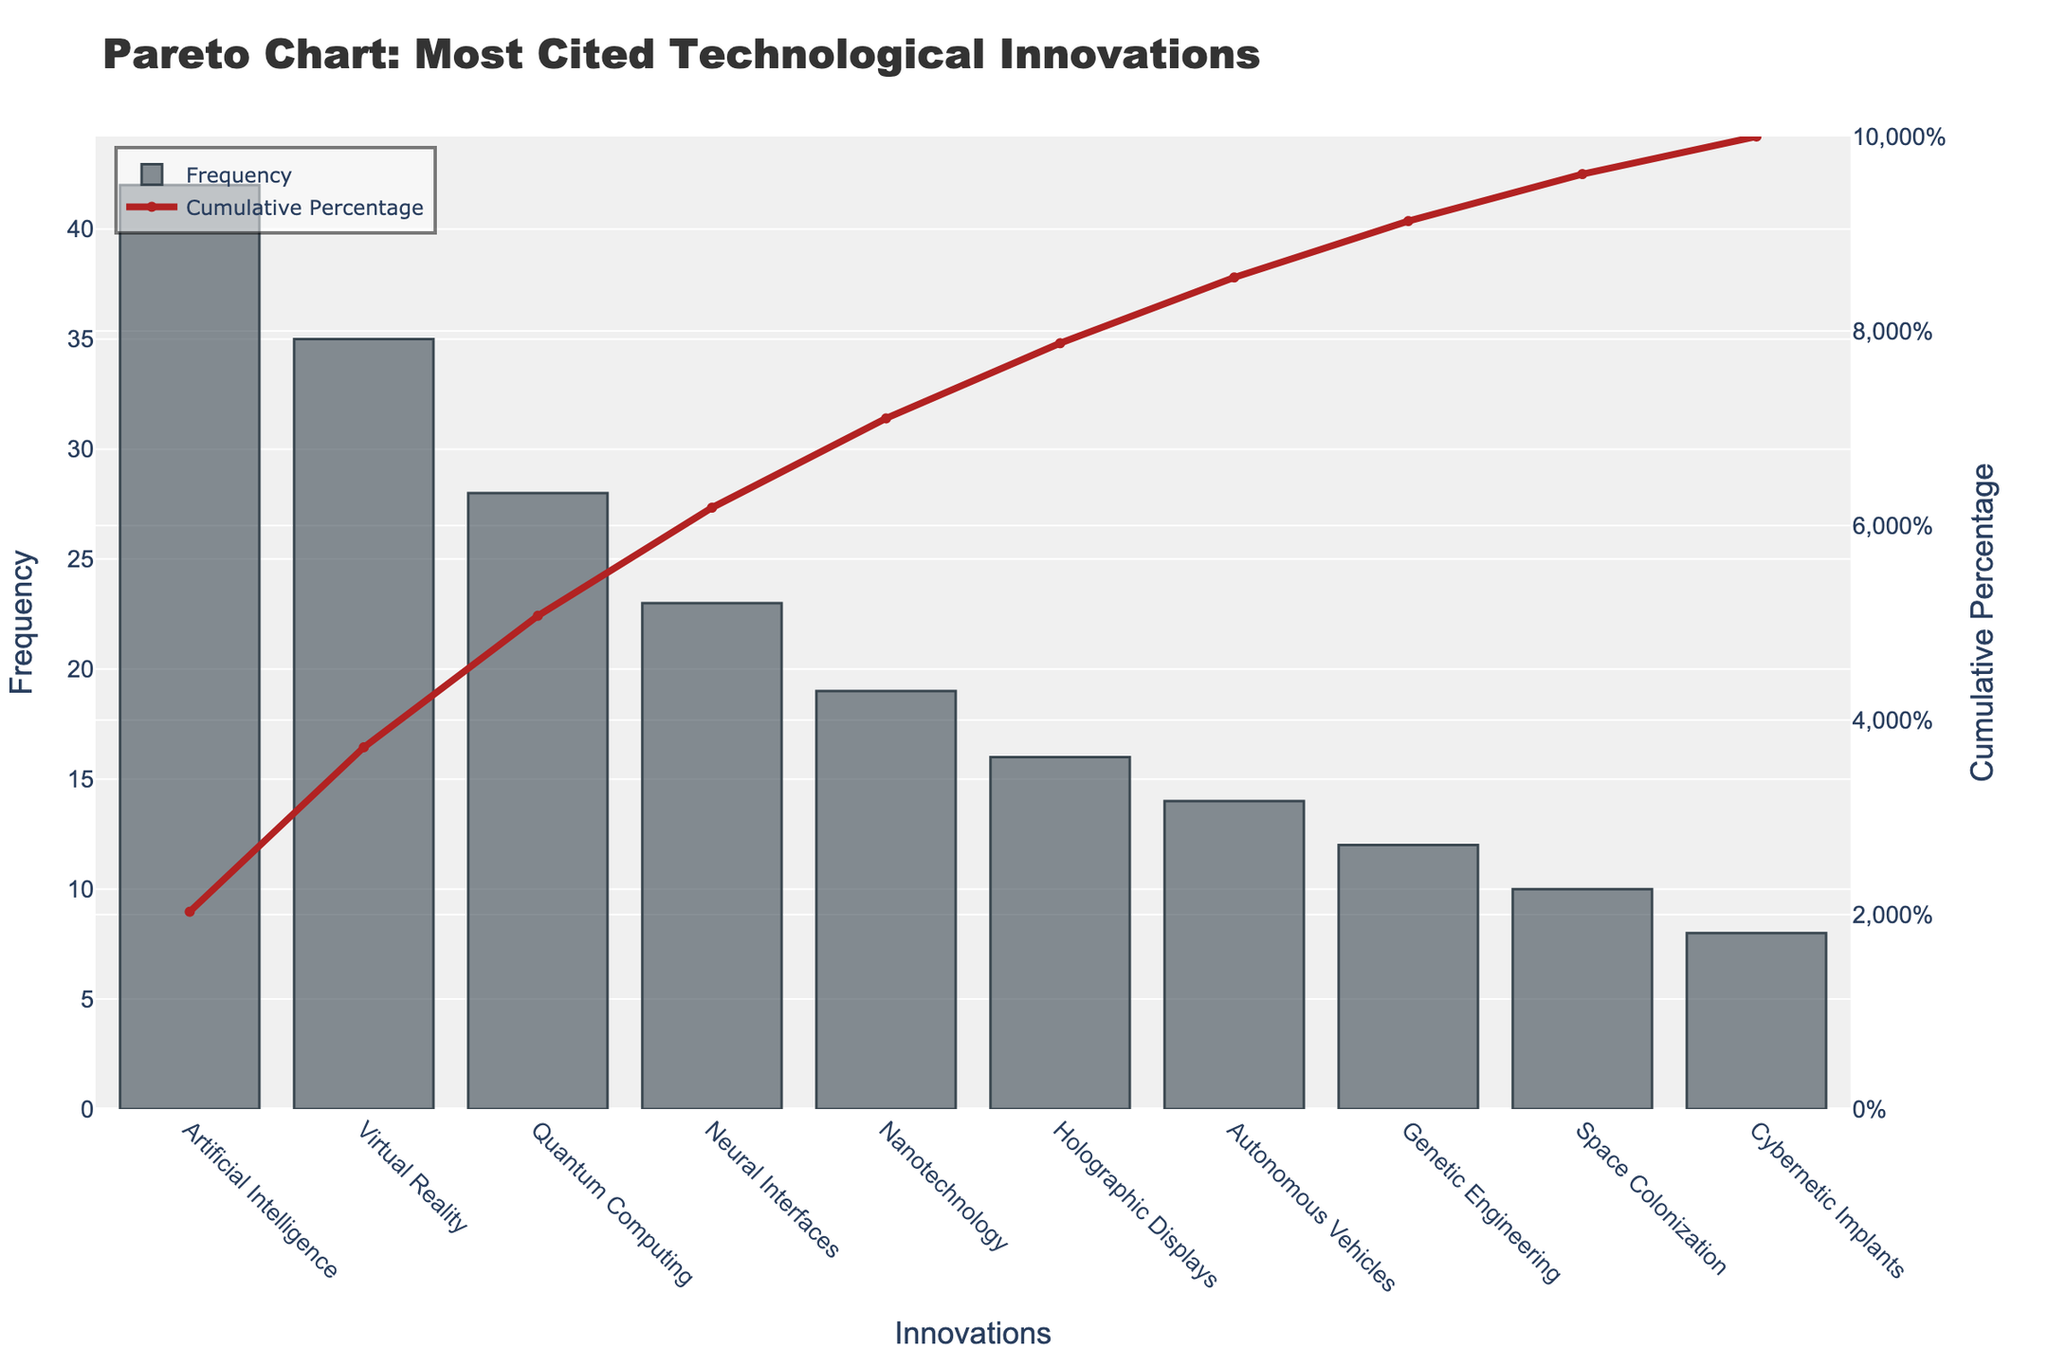What is the title of the chart? The title of the chart is located at the top and is typically one of the most noticeable elements. By looking at the chart, the title reads 'Pareto Chart: Most Cited Technological Innovations'.
Answer: Pareto Chart: Most Cited Technological Innovations Which technological innovation has the highest frequency? The bar representing the frequency of 'Artificial Intelligence' is the tallest, indicating it has the highest frequency.
Answer: Artificial Intelligence What is the cumulative percentage for 'Quantum Computing'? The line plot gives the cumulative percentage for each innovation. For 'Quantum Computing', follow the line to see where it intersects at 95%.
Answer: 95% What are the first three most cited technological innovations? The first three bars from the left indicate the top three most cited innovations: 'Artificial Intelligence', 'Virtual Reality', and 'Quantum Computing'.
Answer: Artificial Intelligence, Virtual Reality, Quantum Computing What is the frequency difference between 'Virtual Reality' and 'Nanotechnology'? The frequency of 'Virtual Reality' is 35 and 'Nanotechnology' is 19. Subtract the latter from the former (35 - 19) to get the difference.
Answer: 16 Which innovation crosses the 80% cumulative percentage mark? The cumulative percentage graph shows the line crossing 80% at 'Neural Interfaces'. By looking at the plot, 'Neural Interfaces' initially crosses at the 80% mark.
Answer: Neural Interfaces Compare the frequencies of 'Autonomous Vehicles' and 'Genetic Engineering'. Look at the height of the bars for 'Autonomous Vehicles' (14) and 'Genetic Engineering' (12). The bar for 'Autonomous Vehicles' is taller by 2 units.
Answer: Autonomous Vehicles > Genetic Engineering How many innovations have a frequency higher than 20? By counting the bars taller than the '20' marker on the frequency axis, we find three: 'Artificial Intelligence', 'Virtual Reality', and 'Quantum Computing'.
Answer: 3 What cumulative percentage does 'Nanotechnology' contribute up to? Find 'Nanotechnology' on the x-axis and follow the line vertically to the cumulative percentage curve. It intersects at approximately 85%.
Answer: 85% What is the combined frequency of the top four technological innovations? Add the frequencies of 'Artificial Intelligence' (42), 'Virtual Reality' (35), 'Quantum Computing' (28), and 'Neural Interfaces' (23). The total is 42 + 35 + 28 + 23 = 128.
Answer: 128 